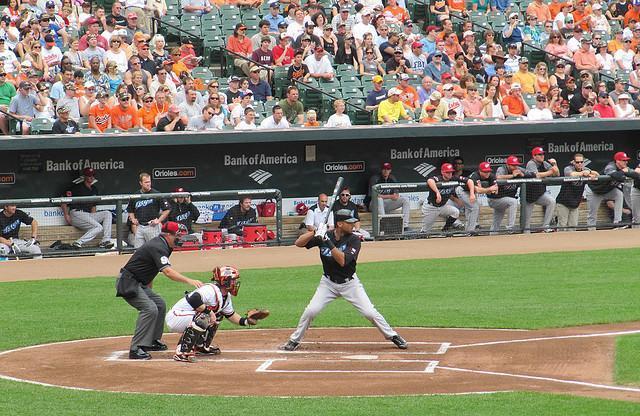How many people are there?
Give a very brief answer. 6. 